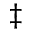Convert formula to latex. <formula><loc_0><loc_0><loc_500><loc_500>{ \ddag }</formula> 